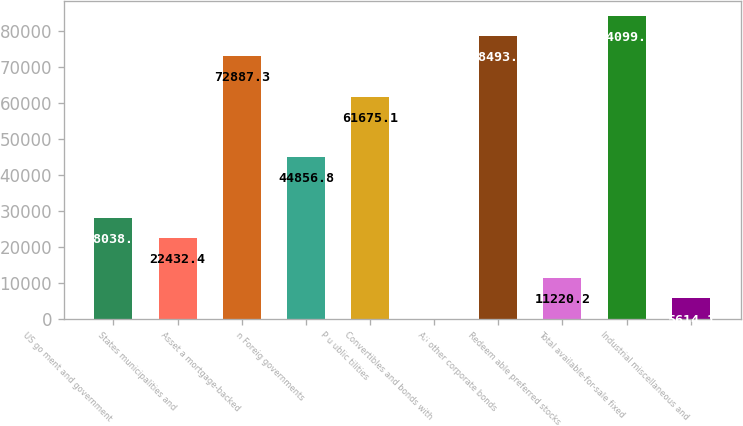Convert chart to OTSL. <chart><loc_0><loc_0><loc_500><loc_500><bar_chart><fcel>US go ment and government<fcel>States municipalities and<fcel>Asset a mortgage-backed<fcel>n Foreig governments<fcel>P u ublic tilities<fcel>Convertibles and bonds with<fcel>All other corporate bonds<fcel>Redeem able preferred stocks<fcel>Total available-for-sale fixed<fcel>Industrial miscellaneous and<nl><fcel>28038.5<fcel>22432.4<fcel>72887.3<fcel>44856.8<fcel>61675.1<fcel>8<fcel>78493.4<fcel>11220.2<fcel>84099.5<fcel>5614.1<nl></chart> 